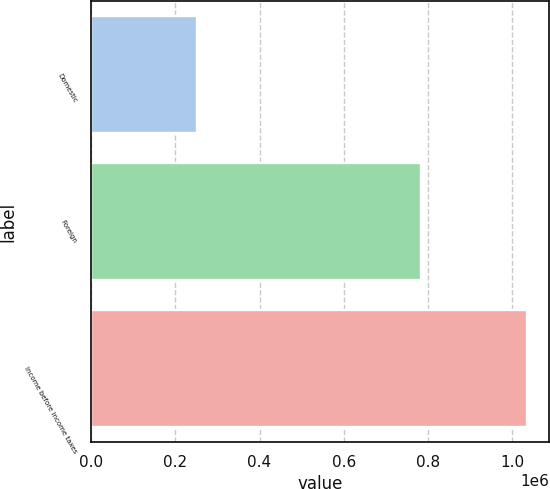<chart> <loc_0><loc_0><loc_500><loc_500><bar_chart><fcel>Domestic<fcel>Foreign<fcel>Income before income taxes<nl><fcel>252476<fcel>782754<fcel>1.03523e+06<nl></chart> 